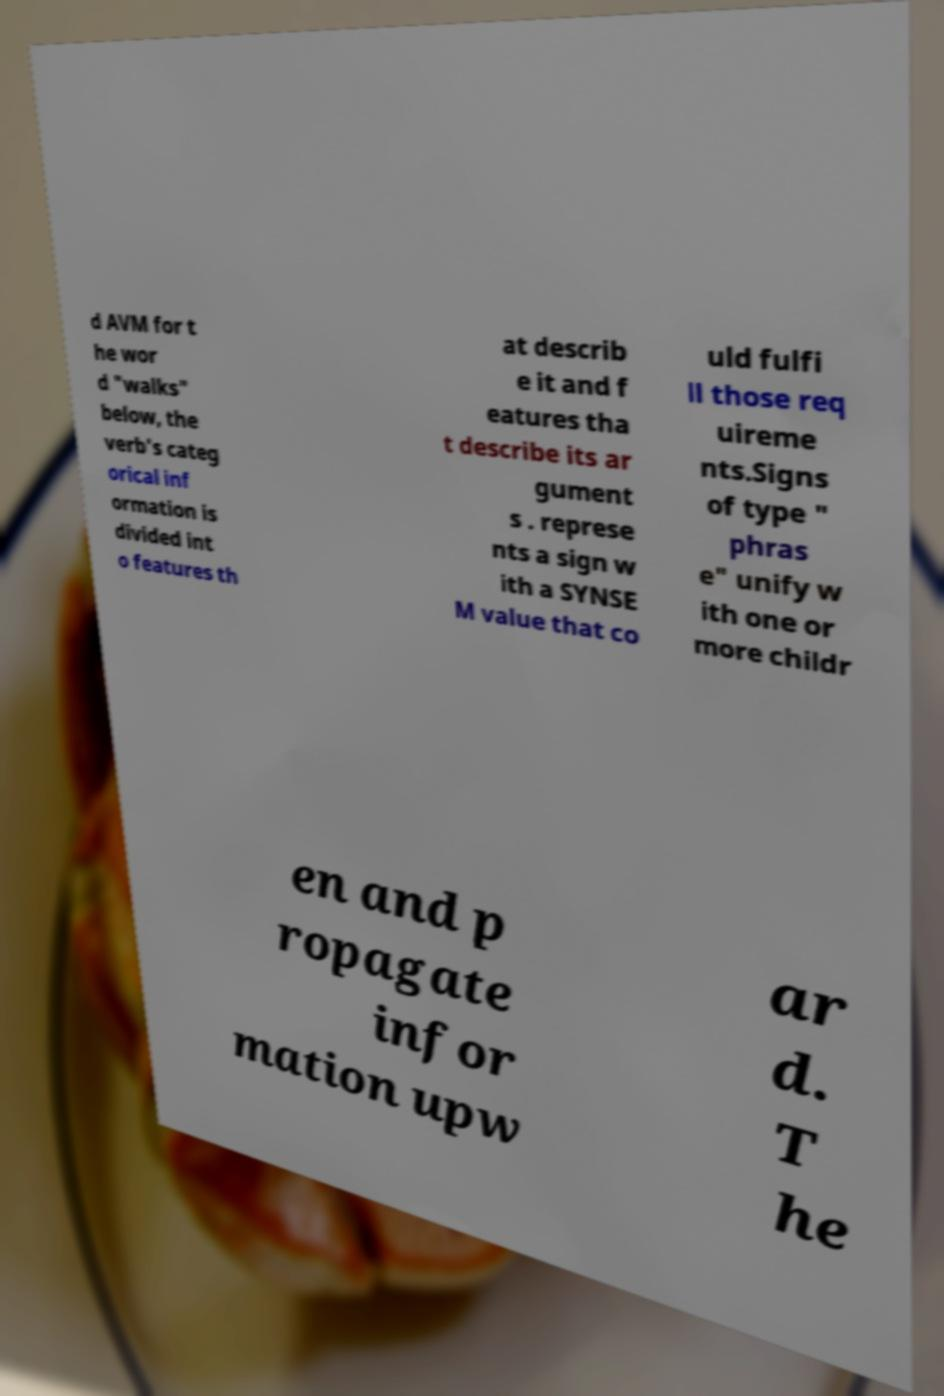There's text embedded in this image that I need extracted. Can you transcribe it verbatim? d AVM for t he wor d "walks" below, the verb's categ orical inf ormation is divided int o features th at describ e it and f eatures tha t describe its ar gument s . represe nts a sign w ith a SYNSE M value that co uld fulfi ll those req uireme nts.Signs of type " phras e" unify w ith one or more childr en and p ropagate infor mation upw ar d. T he 